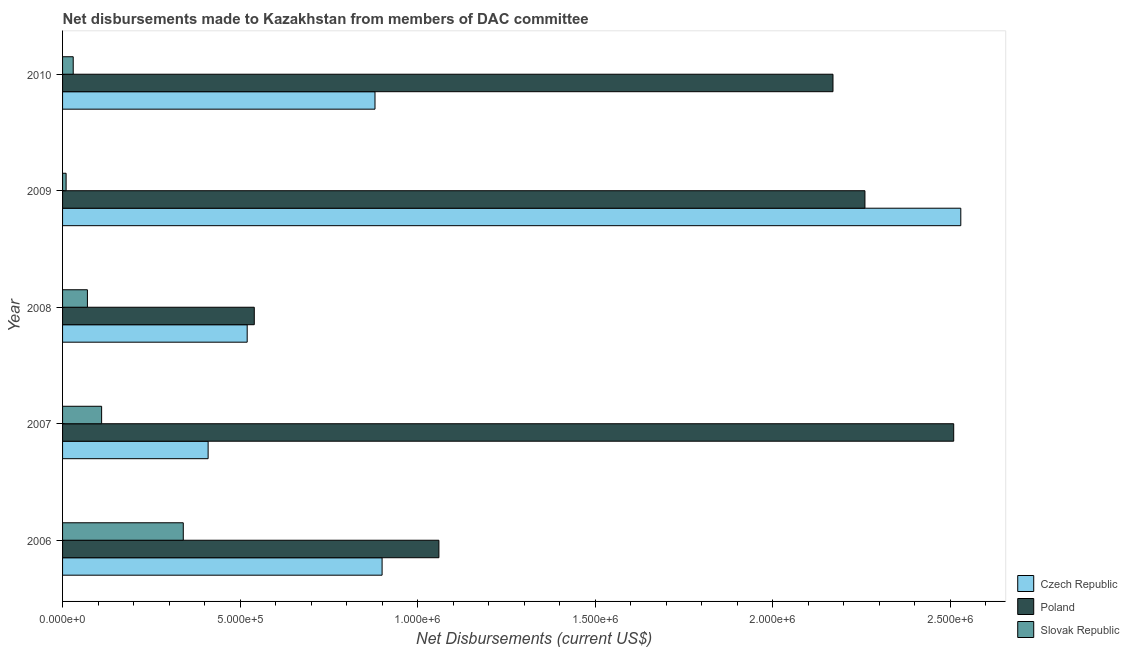How many different coloured bars are there?
Your response must be concise. 3. Are the number of bars on each tick of the Y-axis equal?
Make the answer very short. Yes. What is the net disbursements made by czech republic in 2006?
Your response must be concise. 9.00e+05. Across all years, what is the maximum net disbursements made by poland?
Provide a succinct answer. 2.51e+06. Across all years, what is the minimum net disbursements made by czech republic?
Offer a terse response. 4.10e+05. In which year was the net disbursements made by poland minimum?
Your answer should be very brief. 2008. What is the total net disbursements made by czech republic in the graph?
Make the answer very short. 5.24e+06. What is the difference between the net disbursements made by slovak republic in 2006 and that in 2009?
Offer a terse response. 3.30e+05. What is the difference between the net disbursements made by czech republic in 2007 and the net disbursements made by slovak republic in 2010?
Make the answer very short. 3.80e+05. What is the average net disbursements made by czech republic per year?
Offer a terse response. 1.05e+06. In the year 2010, what is the difference between the net disbursements made by czech republic and net disbursements made by slovak republic?
Offer a very short reply. 8.50e+05. What is the ratio of the net disbursements made by slovak republic in 2009 to that in 2010?
Ensure brevity in your answer.  0.33. Is the difference between the net disbursements made by czech republic in 2006 and 2007 greater than the difference between the net disbursements made by poland in 2006 and 2007?
Make the answer very short. Yes. What is the difference between the highest and the second highest net disbursements made by poland?
Keep it short and to the point. 2.50e+05. What is the difference between the highest and the lowest net disbursements made by poland?
Ensure brevity in your answer.  1.97e+06. In how many years, is the net disbursements made by poland greater than the average net disbursements made by poland taken over all years?
Give a very brief answer. 3. What does the 3rd bar from the top in 2009 represents?
Offer a terse response. Czech Republic. What does the 3rd bar from the bottom in 2009 represents?
Keep it short and to the point. Slovak Republic. Is it the case that in every year, the sum of the net disbursements made by czech republic and net disbursements made by poland is greater than the net disbursements made by slovak republic?
Your response must be concise. Yes. How many bars are there?
Your answer should be very brief. 15. Are all the bars in the graph horizontal?
Give a very brief answer. Yes. Are the values on the major ticks of X-axis written in scientific E-notation?
Your answer should be very brief. Yes. Does the graph contain grids?
Offer a terse response. No. How many legend labels are there?
Your answer should be compact. 3. What is the title of the graph?
Your answer should be very brief. Net disbursements made to Kazakhstan from members of DAC committee. What is the label or title of the X-axis?
Your response must be concise. Net Disbursements (current US$). What is the Net Disbursements (current US$) in Poland in 2006?
Provide a short and direct response. 1.06e+06. What is the Net Disbursements (current US$) in Slovak Republic in 2006?
Offer a very short reply. 3.40e+05. What is the Net Disbursements (current US$) of Poland in 2007?
Ensure brevity in your answer.  2.51e+06. What is the Net Disbursements (current US$) of Slovak Republic in 2007?
Make the answer very short. 1.10e+05. What is the Net Disbursements (current US$) of Czech Republic in 2008?
Your answer should be compact. 5.20e+05. What is the Net Disbursements (current US$) of Poland in 2008?
Ensure brevity in your answer.  5.40e+05. What is the Net Disbursements (current US$) in Czech Republic in 2009?
Give a very brief answer. 2.53e+06. What is the Net Disbursements (current US$) in Poland in 2009?
Your answer should be compact. 2.26e+06. What is the Net Disbursements (current US$) in Slovak Republic in 2009?
Give a very brief answer. 10000. What is the Net Disbursements (current US$) of Czech Republic in 2010?
Give a very brief answer. 8.80e+05. What is the Net Disbursements (current US$) in Poland in 2010?
Your response must be concise. 2.17e+06. What is the Net Disbursements (current US$) in Slovak Republic in 2010?
Your answer should be very brief. 3.00e+04. Across all years, what is the maximum Net Disbursements (current US$) in Czech Republic?
Give a very brief answer. 2.53e+06. Across all years, what is the maximum Net Disbursements (current US$) of Poland?
Keep it short and to the point. 2.51e+06. Across all years, what is the minimum Net Disbursements (current US$) in Poland?
Provide a short and direct response. 5.40e+05. Across all years, what is the minimum Net Disbursements (current US$) in Slovak Republic?
Provide a short and direct response. 10000. What is the total Net Disbursements (current US$) in Czech Republic in the graph?
Your answer should be compact. 5.24e+06. What is the total Net Disbursements (current US$) of Poland in the graph?
Keep it short and to the point. 8.54e+06. What is the total Net Disbursements (current US$) of Slovak Republic in the graph?
Make the answer very short. 5.60e+05. What is the difference between the Net Disbursements (current US$) in Czech Republic in 2006 and that in 2007?
Provide a short and direct response. 4.90e+05. What is the difference between the Net Disbursements (current US$) in Poland in 2006 and that in 2007?
Offer a terse response. -1.45e+06. What is the difference between the Net Disbursements (current US$) in Slovak Republic in 2006 and that in 2007?
Give a very brief answer. 2.30e+05. What is the difference between the Net Disbursements (current US$) in Czech Republic in 2006 and that in 2008?
Offer a terse response. 3.80e+05. What is the difference between the Net Disbursements (current US$) of Poland in 2006 and that in 2008?
Offer a very short reply. 5.20e+05. What is the difference between the Net Disbursements (current US$) of Slovak Republic in 2006 and that in 2008?
Provide a short and direct response. 2.70e+05. What is the difference between the Net Disbursements (current US$) of Czech Republic in 2006 and that in 2009?
Ensure brevity in your answer.  -1.63e+06. What is the difference between the Net Disbursements (current US$) in Poland in 2006 and that in 2009?
Make the answer very short. -1.20e+06. What is the difference between the Net Disbursements (current US$) of Czech Republic in 2006 and that in 2010?
Your response must be concise. 2.00e+04. What is the difference between the Net Disbursements (current US$) of Poland in 2006 and that in 2010?
Your answer should be compact. -1.11e+06. What is the difference between the Net Disbursements (current US$) of Slovak Republic in 2006 and that in 2010?
Provide a succinct answer. 3.10e+05. What is the difference between the Net Disbursements (current US$) in Poland in 2007 and that in 2008?
Provide a succinct answer. 1.97e+06. What is the difference between the Net Disbursements (current US$) in Czech Republic in 2007 and that in 2009?
Your answer should be very brief. -2.12e+06. What is the difference between the Net Disbursements (current US$) of Czech Republic in 2007 and that in 2010?
Your answer should be very brief. -4.70e+05. What is the difference between the Net Disbursements (current US$) in Poland in 2007 and that in 2010?
Keep it short and to the point. 3.40e+05. What is the difference between the Net Disbursements (current US$) of Slovak Republic in 2007 and that in 2010?
Your answer should be very brief. 8.00e+04. What is the difference between the Net Disbursements (current US$) in Czech Republic in 2008 and that in 2009?
Make the answer very short. -2.01e+06. What is the difference between the Net Disbursements (current US$) of Poland in 2008 and that in 2009?
Provide a short and direct response. -1.72e+06. What is the difference between the Net Disbursements (current US$) in Czech Republic in 2008 and that in 2010?
Keep it short and to the point. -3.60e+05. What is the difference between the Net Disbursements (current US$) in Poland in 2008 and that in 2010?
Your response must be concise. -1.63e+06. What is the difference between the Net Disbursements (current US$) in Czech Republic in 2009 and that in 2010?
Your response must be concise. 1.65e+06. What is the difference between the Net Disbursements (current US$) in Poland in 2009 and that in 2010?
Make the answer very short. 9.00e+04. What is the difference between the Net Disbursements (current US$) of Czech Republic in 2006 and the Net Disbursements (current US$) of Poland in 2007?
Provide a succinct answer. -1.61e+06. What is the difference between the Net Disbursements (current US$) of Czech Republic in 2006 and the Net Disbursements (current US$) of Slovak Republic in 2007?
Your answer should be compact. 7.90e+05. What is the difference between the Net Disbursements (current US$) in Poland in 2006 and the Net Disbursements (current US$) in Slovak Republic in 2007?
Make the answer very short. 9.50e+05. What is the difference between the Net Disbursements (current US$) in Czech Republic in 2006 and the Net Disbursements (current US$) in Slovak Republic in 2008?
Offer a terse response. 8.30e+05. What is the difference between the Net Disbursements (current US$) of Poland in 2006 and the Net Disbursements (current US$) of Slovak Republic in 2008?
Keep it short and to the point. 9.90e+05. What is the difference between the Net Disbursements (current US$) of Czech Republic in 2006 and the Net Disbursements (current US$) of Poland in 2009?
Ensure brevity in your answer.  -1.36e+06. What is the difference between the Net Disbursements (current US$) in Czech Republic in 2006 and the Net Disbursements (current US$) in Slovak Republic in 2009?
Provide a short and direct response. 8.90e+05. What is the difference between the Net Disbursements (current US$) in Poland in 2006 and the Net Disbursements (current US$) in Slovak Republic in 2009?
Your answer should be very brief. 1.05e+06. What is the difference between the Net Disbursements (current US$) of Czech Republic in 2006 and the Net Disbursements (current US$) of Poland in 2010?
Ensure brevity in your answer.  -1.27e+06. What is the difference between the Net Disbursements (current US$) in Czech Republic in 2006 and the Net Disbursements (current US$) in Slovak Republic in 2010?
Provide a short and direct response. 8.70e+05. What is the difference between the Net Disbursements (current US$) of Poland in 2006 and the Net Disbursements (current US$) of Slovak Republic in 2010?
Give a very brief answer. 1.03e+06. What is the difference between the Net Disbursements (current US$) of Czech Republic in 2007 and the Net Disbursements (current US$) of Poland in 2008?
Make the answer very short. -1.30e+05. What is the difference between the Net Disbursements (current US$) of Poland in 2007 and the Net Disbursements (current US$) of Slovak Republic in 2008?
Offer a terse response. 2.44e+06. What is the difference between the Net Disbursements (current US$) of Czech Republic in 2007 and the Net Disbursements (current US$) of Poland in 2009?
Provide a succinct answer. -1.85e+06. What is the difference between the Net Disbursements (current US$) of Poland in 2007 and the Net Disbursements (current US$) of Slovak Republic in 2009?
Your answer should be very brief. 2.50e+06. What is the difference between the Net Disbursements (current US$) of Czech Republic in 2007 and the Net Disbursements (current US$) of Poland in 2010?
Your response must be concise. -1.76e+06. What is the difference between the Net Disbursements (current US$) of Czech Republic in 2007 and the Net Disbursements (current US$) of Slovak Republic in 2010?
Ensure brevity in your answer.  3.80e+05. What is the difference between the Net Disbursements (current US$) in Poland in 2007 and the Net Disbursements (current US$) in Slovak Republic in 2010?
Provide a short and direct response. 2.48e+06. What is the difference between the Net Disbursements (current US$) of Czech Republic in 2008 and the Net Disbursements (current US$) of Poland in 2009?
Give a very brief answer. -1.74e+06. What is the difference between the Net Disbursements (current US$) in Czech Republic in 2008 and the Net Disbursements (current US$) in Slovak Republic in 2009?
Your response must be concise. 5.10e+05. What is the difference between the Net Disbursements (current US$) of Poland in 2008 and the Net Disbursements (current US$) of Slovak Republic in 2009?
Your answer should be compact. 5.30e+05. What is the difference between the Net Disbursements (current US$) in Czech Republic in 2008 and the Net Disbursements (current US$) in Poland in 2010?
Provide a short and direct response. -1.65e+06. What is the difference between the Net Disbursements (current US$) in Czech Republic in 2008 and the Net Disbursements (current US$) in Slovak Republic in 2010?
Offer a terse response. 4.90e+05. What is the difference between the Net Disbursements (current US$) in Poland in 2008 and the Net Disbursements (current US$) in Slovak Republic in 2010?
Make the answer very short. 5.10e+05. What is the difference between the Net Disbursements (current US$) of Czech Republic in 2009 and the Net Disbursements (current US$) of Slovak Republic in 2010?
Make the answer very short. 2.50e+06. What is the difference between the Net Disbursements (current US$) in Poland in 2009 and the Net Disbursements (current US$) in Slovak Republic in 2010?
Provide a succinct answer. 2.23e+06. What is the average Net Disbursements (current US$) of Czech Republic per year?
Your answer should be very brief. 1.05e+06. What is the average Net Disbursements (current US$) in Poland per year?
Your answer should be compact. 1.71e+06. What is the average Net Disbursements (current US$) of Slovak Republic per year?
Your answer should be compact. 1.12e+05. In the year 2006, what is the difference between the Net Disbursements (current US$) of Czech Republic and Net Disbursements (current US$) of Poland?
Provide a succinct answer. -1.60e+05. In the year 2006, what is the difference between the Net Disbursements (current US$) in Czech Republic and Net Disbursements (current US$) in Slovak Republic?
Make the answer very short. 5.60e+05. In the year 2006, what is the difference between the Net Disbursements (current US$) of Poland and Net Disbursements (current US$) of Slovak Republic?
Provide a succinct answer. 7.20e+05. In the year 2007, what is the difference between the Net Disbursements (current US$) of Czech Republic and Net Disbursements (current US$) of Poland?
Give a very brief answer. -2.10e+06. In the year 2007, what is the difference between the Net Disbursements (current US$) of Poland and Net Disbursements (current US$) of Slovak Republic?
Ensure brevity in your answer.  2.40e+06. In the year 2008, what is the difference between the Net Disbursements (current US$) of Poland and Net Disbursements (current US$) of Slovak Republic?
Your answer should be very brief. 4.70e+05. In the year 2009, what is the difference between the Net Disbursements (current US$) of Czech Republic and Net Disbursements (current US$) of Slovak Republic?
Keep it short and to the point. 2.52e+06. In the year 2009, what is the difference between the Net Disbursements (current US$) in Poland and Net Disbursements (current US$) in Slovak Republic?
Your response must be concise. 2.25e+06. In the year 2010, what is the difference between the Net Disbursements (current US$) in Czech Republic and Net Disbursements (current US$) in Poland?
Give a very brief answer. -1.29e+06. In the year 2010, what is the difference between the Net Disbursements (current US$) in Czech Republic and Net Disbursements (current US$) in Slovak Republic?
Give a very brief answer. 8.50e+05. In the year 2010, what is the difference between the Net Disbursements (current US$) of Poland and Net Disbursements (current US$) of Slovak Republic?
Offer a very short reply. 2.14e+06. What is the ratio of the Net Disbursements (current US$) in Czech Republic in 2006 to that in 2007?
Give a very brief answer. 2.2. What is the ratio of the Net Disbursements (current US$) of Poland in 2006 to that in 2007?
Make the answer very short. 0.42. What is the ratio of the Net Disbursements (current US$) of Slovak Republic in 2006 to that in 2007?
Give a very brief answer. 3.09. What is the ratio of the Net Disbursements (current US$) of Czech Republic in 2006 to that in 2008?
Provide a short and direct response. 1.73. What is the ratio of the Net Disbursements (current US$) of Poland in 2006 to that in 2008?
Offer a terse response. 1.96. What is the ratio of the Net Disbursements (current US$) in Slovak Republic in 2006 to that in 2008?
Make the answer very short. 4.86. What is the ratio of the Net Disbursements (current US$) in Czech Republic in 2006 to that in 2009?
Offer a very short reply. 0.36. What is the ratio of the Net Disbursements (current US$) of Poland in 2006 to that in 2009?
Keep it short and to the point. 0.47. What is the ratio of the Net Disbursements (current US$) in Czech Republic in 2006 to that in 2010?
Make the answer very short. 1.02. What is the ratio of the Net Disbursements (current US$) in Poland in 2006 to that in 2010?
Your response must be concise. 0.49. What is the ratio of the Net Disbursements (current US$) of Slovak Republic in 2006 to that in 2010?
Keep it short and to the point. 11.33. What is the ratio of the Net Disbursements (current US$) in Czech Republic in 2007 to that in 2008?
Offer a terse response. 0.79. What is the ratio of the Net Disbursements (current US$) of Poland in 2007 to that in 2008?
Your response must be concise. 4.65. What is the ratio of the Net Disbursements (current US$) in Slovak Republic in 2007 to that in 2008?
Keep it short and to the point. 1.57. What is the ratio of the Net Disbursements (current US$) in Czech Republic in 2007 to that in 2009?
Make the answer very short. 0.16. What is the ratio of the Net Disbursements (current US$) of Poland in 2007 to that in 2009?
Your answer should be compact. 1.11. What is the ratio of the Net Disbursements (current US$) of Slovak Republic in 2007 to that in 2009?
Provide a short and direct response. 11. What is the ratio of the Net Disbursements (current US$) of Czech Republic in 2007 to that in 2010?
Your answer should be compact. 0.47. What is the ratio of the Net Disbursements (current US$) of Poland in 2007 to that in 2010?
Ensure brevity in your answer.  1.16. What is the ratio of the Net Disbursements (current US$) of Slovak Republic in 2007 to that in 2010?
Your answer should be compact. 3.67. What is the ratio of the Net Disbursements (current US$) of Czech Republic in 2008 to that in 2009?
Make the answer very short. 0.21. What is the ratio of the Net Disbursements (current US$) in Poland in 2008 to that in 2009?
Your answer should be very brief. 0.24. What is the ratio of the Net Disbursements (current US$) of Slovak Republic in 2008 to that in 2009?
Offer a terse response. 7. What is the ratio of the Net Disbursements (current US$) in Czech Republic in 2008 to that in 2010?
Give a very brief answer. 0.59. What is the ratio of the Net Disbursements (current US$) in Poland in 2008 to that in 2010?
Your answer should be very brief. 0.25. What is the ratio of the Net Disbursements (current US$) in Slovak Republic in 2008 to that in 2010?
Your answer should be very brief. 2.33. What is the ratio of the Net Disbursements (current US$) of Czech Republic in 2009 to that in 2010?
Your answer should be very brief. 2.88. What is the ratio of the Net Disbursements (current US$) in Poland in 2009 to that in 2010?
Make the answer very short. 1.04. What is the ratio of the Net Disbursements (current US$) of Slovak Republic in 2009 to that in 2010?
Offer a terse response. 0.33. What is the difference between the highest and the second highest Net Disbursements (current US$) of Czech Republic?
Give a very brief answer. 1.63e+06. What is the difference between the highest and the second highest Net Disbursements (current US$) in Slovak Republic?
Give a very brief answer. 2.30e+05. What is the difference between the highest and the lowest Net Disbursements (current US$) of Czech Republic?
Your response must be concise. 2.12e+06. What is the difference between the highest and the lowest Net Disbursements (current US$) in Poland?
Give a very brief answer. 1.97e+06. 